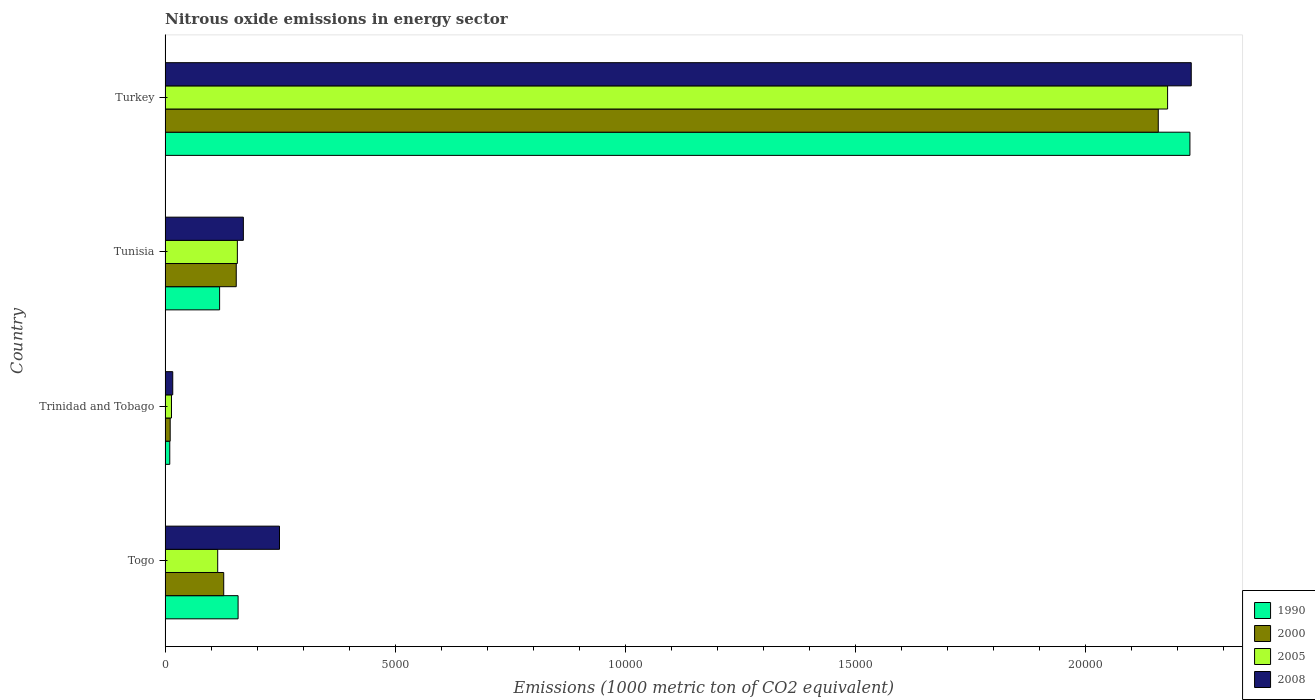How many different coloured bars are there?
Your answer should be compact. 4. How many groups of bars are there?
Make the answer very short. 4. Are the number of bars per tick equal to the number of legend labels?
Make the answer very short. Yes. How many bars are there on the 4th tick from the bottom?
Your answer should be compact. 4. What is the label of the 3rd group of bars from the top?
Offer a very short reply. Trinidad and Tobago. In how many cases, is the number of bars for a given country not equal to the number of legend labels?
Your answer should be compact. 0. What is the amount of nitrous oxide emitted in 2008 in Togo?
Your answer should be very brief. 2485.1. Across all countries, what is the maximum amount of nitrous oxide emitted in 1990?
Keep it short and to the point. 2.23e+04. Across all countries, what is the minimum amount of nitrous oxide emitted in 2005?
Your response must be concise. 138.8. In which country was the amount of nitrous oxide emitted in 2008 minimum?
Your answer should be compact. Trinidad and Tobago. What is the total amount of nitrous oxide emitted in 2008 in the graph?
Your response must be concise. 2.66e+04. What is the difference between the amount of nitrous oxide emitted in 2008 in Trinidad and Tobago and that in Turkey?
Provide a short and direct response. -2.21e+04. What is the difference between the amount of nitrous oxide emitted in 1990 in Togo and the amount of nitrous oxide emitted in 2005 in Turkey?
Keep it short and to the point. -2.02e+04. What is the average amount of nitrous oxide emitted in 2008 per country?
Your answer should be compact. 6660.77. What is the difference between the amount of nitrous oxide emitted in 2005 and amount of nitrous oxide emitted in 1990 in Trinidad and Tobago?
Provide a short and direct response. 37.5. In how many countries, is the amount of nitrous oxide emitted in 2008 greater than 11000 1000 metric ton?
Your answer should be very brief. 1. What is the ratio of the amount of nitrous oxide emitted in 1990 in Trinidad and Tobago to that in Turkey?
Keep it short and to the point. 0. Is the difference between the amount of nitrous oxide emitted in 2005 in Togo and Tunisia greater than the difference between the amount of nitrous oxide emitted in 1990 in Togo and Tunisia?
Offer a very short reply. No. What is the difference between the highest and the second highest amount of nitrous oxide emitted in 2008?
Make the answer very short. 1.98e+04. What is the difference between the highest and the lowest amount of nitrous oxide emitted in 2008?
Your answer should be compact. 2.21e+04. Is it the case that in every country, the sum of the amount of nitrous oxide emitted in 2005 and amount of nitrous oxide emitted in 2008 is greater than the sum of amount of nitrous oxide emitted in 1990 and amount of nitrous oxide emitted in 2000?
Give a very brief answer. No. How many bars are there?
Offer a terse response. 16. What is the difference between two consecutive major ticks on the X-axis?
Give a very brief answer. 5000. Where does the legend appear in the graph?
Ensure brevity in your answer.  Bottom right. How are the legend labels stacked?
Offer a terse response. Vertical. What is the title of the graph?
Provide a short and direct response. Nitrous oxide emissions in energy sector. What is the label or title of the X-axis?
Offer a terse response. Emissions (1000 metric ton of CO2 equivalent). What is the Emissions (1000 metric ton of CO2 equivalent) of 1990 in Togo?
Keep it short and to the point. 1585.7. What is the Emissions (1000 metric ton of CO2 equivalent) in 2000 in Togo?
Make the answer very short. 1273.3. What is the Emissions (1000 metric ton of CO2 equivalent) of 2005 in Togo?
Your answer should be very brief. 1142.8. What is the Emissions (1000 metric ton of CO2 equivalent) of 2008 in Togo?
Offer a terse response. 2485.1. What is the Emissions (1000 metric ton of CO2 equivalent) of 1990 in Trinidad and Tobago?
Your answer should be compact. 101.3. What is the Emissions (1000 metric ton of CO2 equivalent) of 2000 in Trinidad and Tobago?
Your response must be concise. 110.5. What is the Emissions (1000 metric ton of CO2 equivalent) in 2005 in Trinidad and Tobago?
Provide a short and direct response. 138.8. What is the Emissions (1000 metric ton of CO2 equivalent) of 2008 in Trinidad and Tobago?
Your answer should be compact. 166.3. What is the Emissions (1000 metric ton of CO2 equivalent) of 1990 in Tunisia?
Give a very brief answer. 1184.1. What is the Emissions (1000 metric ton of CO2 equivalent) of 2000 in Tunisia?
Keep it short and to the point. 1545.6. What is the Emissions (1000 metric ton of CO2 equivalent) in 2005 in Tunisia?
Your response must be concise. 1569.7. What is the Emissions (1000 metric ton of CO2 equivalent) of 2008 in Tunisia?
Your answer should be compact. 1700. What is the Emissions (1000 metric ton of CO2 equivalent) in 1990 in Turkey?
Ensure brevity in your answer.  2.23e+04. What is the Emissions (1000 metric ton of CO2 equivalent) of 2000 in Turkey?
Offer a very short reply. 2.16e+04. What is the Emissions (1000 metric ton of CO2 equivalent) of 2005 in Turkey?
Offer a very short reply. 2.18e+04. What is the Emissions (1000 metric ton of CO2 equivalent) in 2008 in Turkey?
Offer a very short reply. 2.23e+04. Across all countries, what is the maximum Emissions (1000 metric ton of CO2 equivalent) of 1990?
Keep it short and to the point. 2.23e+04. Across all countries, what is the maximum Emissions (1000 metric ton of CO2 equivalent) of 2000?
Your answer should be very brief. 2.16e+04. Across all countries, what is the maximum Emissions (1000 metric ton of CO2 equivalent) of 2005?
Offer a terse response. 2.18e+04. Across all countries, what is the maximum Emissions (1000 metric ton of CO2 equivalent) of 2008?
Provide a succinct answer. 2.23e+04. Across all countries, what is the minimum Emissions (1000 metric ton of CO2 equivalent) of 1990?
Make the answer very short. 101.3. Across all countries, what is the minimum Emissions (1000 metric ton of CO2 equivalent) of 2000?
Your answer should be compact. 110.5. Across all countries, what is the minimum Emissions (1000 metric ton of CO2 equivalent) of 2005?
Offer a very short reply. 138.8. Across all countries, what is the minimum Emissions (1000 metric ton of CO2 equivalent) in 2008?
Ensure brevity in your answer.  166.3. What is the total Emissions (1000 metric ton of CO2 equivalent) in 1990 in the graph?
Ensure brevity in your answer.  2.51e+04. What is the total Emissions (1000 metric ton of CO2 equivalent) in 2000 in the graph?
Provide a short and direct response. 2.45e+04. What is the total Emissions (1000 metric ton of CO2 equivalent) in 2005 in the graph?
Offer a very short reply. 2.46e+04. What is the total Emissions (1000 metric ton of CO2 equivalent) of 2008 in the graph?
Your response must be concise. 2.66e+04. What is the difference between the Emissions (1000 metric ton of CO2 equivalent) of 1990 in Togo and that in Trinidad and Tobago?
Provide a succinct answer. 1484.4. What is the difference between the Emissions (1000 metric ton of CO2 equivalent) in 2000 in Togo and that in Trinidad and Tobago?
Make the answer very short. 1162.8. What is the difference between the Emissions (1000 metric ton of CO2 equivalent) of 2005 in Togo and that in Trinidad and Tobago?
Your response must be concise. 1004. What is the difference between the Emissions (1000 metric ton of CO2 equivalent) in 2008 in Togo and that in Trinidad and Tobago?
Your answer should be compact. 2318.8. What is the difference between the Emissions (1000 metric ton of CO2 equivalent) of 1990 in Togo and that in Tunisia?
Your answer should be compact. 401.6. What is the difference between the Emissions (1000 metric ton of CO2 equivalent) of 2000 in Togo and that in Tunisia?
Ensure brevity in your answer.  -272.3. What is the difference between the Emissions (1000 metric ton of CO2 equivalent) in 2005 in Togo and that in Tunisia?
Your answer should be compact. -426.9. What is the difference between the Emissions (1000 metric ton of CO2 equivalent) in 2008 in Togo and that in Tunisia?
Provide a short and direct response. 785.1. What is the difference between the Emissions (1000 metric ton of CO2 equivalent) in 1990 in Togo and that in Turkey?
Keep it short and to the point. -2.07e+04. What is the difference between the Emissions (1000 metric ton of CO2 equivalent) in 2000 in Togo and that in Turkey?
Make the answer very short. -2.03e+04. What is the difference between the Emissions (1000 metric ton of CO2 equivalent) of 2005 in Togo and that in Turkey?
Offer a very short reply. -2.06e+04. What is the difference between the Emissions (1000 metric ton of CO2 equivalent) of 2008 in Togo and that in Turkey?
Offer a terse response. -1.98e+04. What is the difference between the Emissions (1000 metric ton of CO2 equivalent) in 1990 in Trinidad and Tobago and that in Tunisia?
Offer a very short reply. -1082.8. What is the difference between the Emissions (1000 metric ton of CO2 equivalent) in 2000 in Trinidad and Tobago and that in Tunisia?
Offer a terse response. -1435.1. What is the difference between the Emissions (1000 metric ton of CO2 equivalent) in 2005 in Trinidad and Tobago and that in Tunisia?
Keep it short and to the point. -1430.9. What is the difference between the Emissions (1000 metric ton of CO2 equivalent) in 2008 in Trinidad and Tobago and that in Tunisia?
Your answer should be very brief. -1533.7. What is the difference between the Emissions (1000 metric ton of CO2 equivalent) of 1990 in Trinidad and Tobago and that in Turkey?
Your response must be concise. -2.22e+04. What is the difference between the Emissions (1000 metric ton of CO2 equivalent) in 2000 in Trinidad and Tobago and that in Turkey?
Keep it short and to the point. -2.15e+04. What is the difference between the Emissions (1000 metric ton of CO2 equivalent) in 2005 in Trinidad and Tobago and that in Turkey?
Keep it short and to the point. -2.16e+04. What is the difference between the Emissions (1000 metric ton of CO2 equivalent) of 2008 in Trinidad and Tobago and that in Turkey?
Provide a succinct answer. -2.21e+04. What is the difference between the Emissions (1000 metric ton of CO2 equivalent) of 1990 in Tunisia and that in Turkey?
Ensure brevity in your answer.  -2.11e+04. What is the difference between the Emissions (1000 metric ton of CO2 equivalent) in 2000 in Tunisia and that in Turkey?
Your answer should be compact. -2.00e+04. What is the difference between the Emissions (1000 metric ton of CO2 equivalent) in 2005 in Tunisia and that in Turkey?
Provide a succinct answer. -2.02e+04. What is the difference between the Emissions (1000 metric ton of CO2 equivalent) in 2008 in Tunisia and that in Turkey?
Keep it short and to the point. -2.06e+04. What is the difference between the Emissions (1000 metric ton of CO2 equivalent) in 1990 in Togo and the Emissions (1000 metric ton of CO2 equivalent) in 2000 in Trinidad and Tobago?
Ensure brevity in your answer.  1475.2. What is the difference between the Emissions (1000 metric ton of CO2 equivalent) of 1990 in Togo and the Emissions (1000 metric ton of CO2 equivalent) of 2005 in Trinidad and Tobago?
Provide a succinct answer. 1446.9. What is the difference between the Emissions (1000 metric ton of CO2 equivalent) in 1990 in Togo and the Emissions (1000 metric ton of CO2 equivalent) in 2008 in Trinidad and Tobago?
Give a very brief answer. 1419.4. What is the difference between the Emissions (1000 metric ton of CO2 equivalent) in 2000 in Togo and the Emissions (1000 metric ton of CO2 equivalent) in 2005 in Trinidad and Tobago?
Offer a very short reply. 1134.5. What is the difference between the Emissions (1000 metric ton of CO2 equivalent) in 2000 in Togo and the Emissions (1000 metric ton of CO2 equivalent) in 2008 in Trinidad and Tobago?
Give a very brief answer. 1107. What is the difference between the Emissions (1000 metric ton of CO2 equivalent) of 2005 in Togo and the Emissions (1000 metric ton of CO2 equivalent) of 2008 in Trinidad and Tobago?
Give a very brief answer. 976.5. What is the difference between the Emissions (1000 metric ton of CO2 equivalent) of 1990 in Togo and the Emissions (1000 metric ton of CO2 equivalent) of 2000 in Tunisia?
Your response must be concise. 40.1. What is the difference between the Emissions (1000 metric ton of CO2 equivalent) of 1990 in Togo and the Emissions (1000 metric ton of CO2 equivalent) of 2005 in Tunisia?
Give a very brief answer. 16. What is the difference between the Emissions (1000 metric ton of CO2 equivalent) in 1990 in Togo and the Emissions (1000 metric ton of CO2 equivalent) in 2008 in Tunisia?
Offer a very short reply. -114.3. What is the difference between the Emissions (1000 metric ton of CO2 equivalent) of 2000 in Togo and the Emissions (1000 metric ton of CO2 equivalent) of 2005 in Tunisia?
Give a very brief answer. -296.4. What is the difference between the Emissions (1000 metric ton of CO2 equivalent) of 2000 in Togo and the Emissions (1000 metric ton of CO2 equivalent) of 2008 in Tunisia?
Offer a very short reply. -426.7. What is the difference between the Emissions (1000 metric ton of CO2 equivalent) of 2005 in Togo and the Emissions (1000 metric ton of CO2 equivalent) of 2008 in Tunisia?
Provide a short and direct response. -557.2. What is the difference between the Emissions (1000 metric ton of CO2 equivalent) in 1990 in Togo and the Emissions (1000 metric ton of CO2 equivalent) in 2000 in Turkey?
Keep it short and to the point. -2.00e+04. What is the difference between the Emissions (1000 metric ton of CO2 equivalent) of 1990 in Togo and the Emissions (1000 metric ton of CO2 equivalent) of 2005 in Turkey?
Offer a terse response. -2.02e+04. What is the difference between the Emissions (1000 metric ton of CO2 equivalent) of 1990 in Togo and the Emissions (1000 metric ton of CO2 equivalent) of 2008 in Turkey?
Provide a succinct answer. -2.07e+04. What is the difference between the Emissions (1000 metric ton of CO2 equivalent) in 2000 in Togo and the Emissions (1000 metric ton of CO2 equivalent) in 2005 in Turkey?
Offer a terse response. -2.05e+04. What is the difference between the Emissions (1000 metric ton of CO2 equivalent) of 2000 in Togo and the Emissions (1000 metric ton of CO2 equivalent) of 2008 in Turkey?
Your response must be concise. -2.10e+04. What is the difference between the Emissions (1000 metric ton of CO2 equivalent) in 2005 in Togo and the Emissions (1000 metric ton of CO2 equivalent) in 2008 in Turkey?
Give a very brief answer. -2.11e+04. What is the difference between the Emissions (1000 metric ton of CO2 equivalent) in 1990 in Trinidad and Tobago and the Emissions (1000 metric ton of CO2 equivalent) in 2000 in Tunisia?
Keep it short and to the point. -1444.3. What is the difference between the Emissions (1000 metric ton of CO2 equivalent) in 1990 in Trinidad and Tobago and the Emissions (1000 metric ton of CO2 equivalent) in 2005 in Tunisia?
Keep it short and to the point. -1468.4. What is the difference between the Emissions (1000 metric ton of CO2 equivalent) of 1990 in Trinidad and Tobago and the Emissions (1000 metric ton of CO2 equivalent) of 2008 in Tunisia?
Your answer should be compact. -1598.7. What is the difference between the Emissions (1000 metric ton of CO2 equivalent) in 2000 in Trinidad and Tobago and the Emissions (1000 metric ton of CO2 equivalent) in 2005 in Tunisia?
Provide a succinct answer. -1459.2. What is the difference between the Emissions (1000 metric ton of CO2 equivalent) in 2000 in Trinidad and Tobago and the Emissions (1000 metric ton of CO2 equivalent) in 2008 in Tunisia?
Provide a succinct answer. -1589.5. What is the difference between the Emissions (1000 metric ton of CO2 equivalent) of 2005 in Trinidad and Tobago and the Emissions (1000 metric ton of CO2 equivalent) of 2008 in Tunisia?
Provide a short and direct response. -1561.2. What is the difference between the Emissions (1000 metric ton of CO2 equivalent) of 1990 in Trinidad and Tobago and the Emissions (1000 metric ton of CO2 equivalent) of 2000 in Turkey?
Ensure brevity in your answer.  -2.15e+04. What is the difference between the Emissions (1000 metric ton of CO2 equivalent) in 1990 in Trinidad and Tobago and the Emissions (1000 metric ton of CO2 equivalent) in 2005 in Turkey?
Provide a succinct answer. -2.17e+04. What is the difference between the Emissions (1000 metric ton of CO2 equivalent) of 1990 in Trinidad and Tobago and the Emissions (1000 metric ton of CO2 equivalent) of 2008 in Turkey?
Your answer should be very brief. -2.22e+04. What is the difference between the Emissions (1000 metric ton of CO2 equivalent) in 2000 in Trinidad and Tobago and the Emissions (1000 metric ton of CO2 equivalent) in 2005 in Turkey?
Your response must be concise. -2.17e+04. What is the difference between the Emissions (1000 metric ton of CO2 equivalent) of 2000 in Trinidad and Tobago and the Emissions (1000 metric ton of CO2 equivalent) of 2008 in Turkey?
Keep it short and to the point. -2.22e+04. What is the difference between the Emissions (1000 metric ton of CO2 equivalent) in 2005 in Trinidad and Tobago and the Emissions (1000 metric ton of CO2 equivalent) in 2008 in Turkey?
Your response must be concise. -2.22e+04. What is the difference between the Emissions (1000 metric ton of CO2 equivalent) of 1990 in Tunisia and the Emissions (1000 metric ton of CO2 equivalent) of 2000 in Turkey?
Offer a very short reply. -2.04e+04. What is the difference between the Emissions (1000 metric ton of CO2 equivalent) in 1990 in Tunisia and the Emissions (1000 metric ton of CO2 equivalent) in 2005 in Turkey?
Offer a terse response. -2.06e+04. What is the difference between the Emissions (1000 metric ton of CO2 equivalent) in 1990 in Tunisia and the Emissions (1000 metric ton of CO2 equivalent) in 2008 in Turkey?
Your answer should be compact. -2.11e+04. What is the difference between the Emissions (1000 metric ton of CO2 equivalent) of 2000 in Tunisia and the Emissions (1000 metric ton of CO2 equivalent) of 2005 in Turkey?
Your answer should be very brief. -2.02e+04. What is the difference between the Emissions (1000 metric ton of CO2 equivalent) of 2000 in Tunisia and the Emissions (1000 metric ton of CO2 equivalent) of 2008 in Turkey?
Your answer should be compact. -2.07e+04. What is the difference between the Emissions (1000 metric ton of CO2 equivalent) in 2005 in Tunisia and the Emissions (1000 metric ton of CO2 equivalent) in 2008 in Turkey?
Offer a terse response. -2.07e+04. What is the average Emissions (1000 metric ton of CO2 equivalent) of 1990 per country?
Offer a terse response. 6283.5. What is the average Emissions (1000 metric ton of CO2 equivalent) of 2000 per country?
Provide a short and direct response. 6126.18. What is the average Emissions (1000 metric ton of CO2 equivalent) in 2005 per country?
Offer a very short reply. 6157.27. What is the average Emissions (1000 metric ton of CO2 equivalent) in 2008 per country?
Provide a short and direct response. 6660.77. What is the difference between the Emissions (1000 metric ton of CO2 equivalent) of 1990 and Emissions (1000 metric ton of CO2 equivalent) of 2000 in Togo?
Provide a succinct answer. 312.4. What is the difference between the Emissions (1000 metric ton of CO2 equivalent) of 1990 and Emissions (1000 metric ton of CO2 equivalent) of 2005 in Togo?
Provide a short and direct response. 442.9. What is the difference between the Emissions (1000 metric ton of CO2 equivalent) of 1990 and Emissions (1000 metric ton of CO2 equivalent) of 2008 in Togo?
Offer a terse response. -899.4. What is the difference between the Emissions (1000 metric ton of CO2 equivalent) in 2000 and Emissions (1000 metric ton of CO2 equivalent) in 2005 in Togo?
Give a very brief answer. 130.5. What is the difference between the Emissions (1000 metric ton of CO2 equivalent) of 2000 and Emissions (1000 metric ton of CO2 equivalent) of 2008 in Togo?
Your response must be concise. -1211.8. What is the difference between the Emissions (1000 metric ton of CO2 equivalent) in 2005 and Emissions (1000 metric ton of CO2 equivalent) in 2008 in Togo?
Offer a very short reply. -1342.3. What is the difference between the Emissions (1000 metric ton of CO2 equivalent) of 1990 and Emissions (1000 metric ton of CO2 equivalent) of 2000 in Trinidad and Tobago?
Provide a short and direct response. -9.2. What is the difference between the Emissions (1000 metric ton of CO2 equivalent) of 1990 and Emissions (1000 metric ton of CO2 equivalent) of 2005 in Trinidad and Tobago?
Ensure brevity in your answer.  -37.5. What is the difference between the Emissions (1000 metric ton of CO2 equivalent) of 1990 and Emissions (1000 metric ton of CO2 equivalent) of 2008 in Trinidad and Tobago?
Provide a short and direct response. -65. What is the difference between the Emissions (1000 metric ton of CO2 equivalent) of 2000 and Emissions (1000 metric ton of CO2 equivalent) of 2005 in Trinidad and Tobago?
Give a very brief answer. -28.3. What is the difference between the Emissions (1000 metric ton of CO2 equivalent) in 2000 and Emissions (1000 metric ton of CO2 equivalent) in 2008 in Trinidad and Tobago?
Make the answer very short. -55.8. What is the difference between the Emissions (1000 metric ton of CO2 equivalent) in 2005 and Emissions (1000 metric ton of CO2 equivalent) in 2008 in Trinidad and Tobago?
Give a very brief answer. -27.5. What is the difference between the Emissions (1000 metric ton of CO2 equivalent) in 1990 and Emissions (1000 metric ton of CO2 equivalent) in 2000 in Tunisia?
Your answer should be very brief. -361.5. What is the difference between the Emissions (1000 metric ton of CO2 equivalent) of 1990 and Emissions (1000 metric ton of CO2 equivalent) of 2005 in Tunisia?
Make the answer very short. -385.6. What is the difference between the Emissions (1000 metric ton of CO2 equivalent) in 1990 and Emissions (1000 metric ton of CO2 equivalent) in 2008 in Tunisia?
Your response must be concise. -515.9. What is the difference between the Emissions (1000 metric ton of CO2 equivalent) in 2000 and Emissions (1000 metric ton of CO2 equivalent) in 2005 in Tunisia?
Keep it short and to the point. -24.1. What is the difference between the Emissions (1000 metric ton of CO2 equivalent) in 2000 and Emissions (1000 metric ton of CO2 equivalent) in 2008 in Tunisia?
Your answer should be compact. -154.4. What is the difference between the Emissions (1000 metric ton of CO2 equivalent) of 2005 and Emissions (1000 metric ton of CO2 equivalent) of 2008 in Tunisia?
Your answer should be compact. -130.3. What is the difference between the Emissions (1000 metric ton of CO2 equivalent) in 1990 and Emissions (1000 metric ton of CO2 equivalent) in 2000 in Turkey?
Ensure brevity in your answer.  687.6. What is the difference between the Emissions (1000 metric ton of CO2 equivalent) in 1990 and Emissions (1000 metric ton of CO2 equivalent) in 2005 in Turkey?
Offer a very short reply. 485.1. What is the difference between the Emissions (1000 metric ton of CO2 equivalent) of 1990 and Emissions (1000 metric ton of CO2 equivalent) of 2008 in Turkey?
Keep it short and to the point. -28.8. What is the difference between the Emissions (1000 metric ton of CO2 equivalent) of 2000 and Emissions (1000 metric ton of CO2 equivalent) of 2005 in Turkey?
Provide a short and direct response. -202.5. What is the difference between the Emissions (1000 metric ton of CO2 equivalent) in 2000 and Emissions (1000 metric ton of CO2 equivalent) in 2008 in Turkey?
Your response must be concise. -716.4. What is the difference between the Emissions (1000 metric ton of CO2 equivalent) in 2005 and Emissions (1000 metric ton of CO2 equivalent) in 2008 in Turkey?
Give a very brief answer. -513.9. What is the ratio of the Emissions (1000 metric ton of CO2 equivalent) of 1990 in Togo to that in Trinidad and Tobago?
Keep it short and to the point. 15.65. What is the ratio of the Emissions (1000 metric ton of CO2 equivalent) of 2000 in Togo to that in Trinidad and Tobago?
Provide a short and direct response. 11.52. What is the ratio of the Emissions (1000 metric ton of CO2 equivalent) in 2005 in Togo to that in Trinidad and Tobago?
Offer a terse response. 8.23. What is the ratio of the Emissions (1000 metric ton of CO2 equivalent) of 2008 in Togo to that in Trinidad and Tobago?
Ensure brevity in your answer.  14.94. What is the ratio of the Emissions (1000 metric ton of CO2 equivalent) of 1990 in Togo to that in Tunisia?
Give a very brief answer. 1.34. What is the ratio of the Emissions (1000 metric ton of CO2 equivalent) in 2000 in Togo to that in Tunisia?
Provide a succinct answer. 0.82. What is the ratio of the Emissions (1000 metric ton of CO2 equivalent) of 2005 in Togo to that in Tunisia?
Provide a short and direct response. 0.73. What is the ratio of the Emissions (1000 metric ton of CO2 equivalent) of 2008 in Togo to that in Tunisia?
Make the answer very short. 1.46. What is the ratio of the Emissions (1000 metric ton of CO2 equivalent) of 1990 in Togo to that in Turkey?
Provide a succinct answer. 0.07. What is the ratio of the Emissions (1000 metric ton of CO2 equivalent) of 2000 in Togo to that in Turkey?
Offer a very short reply. 0.06. What is the ratio of the Emissions (1000 metric ton of CO2 equivalent) in 2005 in Togo to that in Turkey?
Provide a succinct answer. 0.05. What is the ratio of the Emissions (1000 metric ton of CO2 equivalent) of 2008 in Togo to that in Turkey?
Provide a short and direct response. 0.11. What is the ratio of the Emissions (1000 metric ton of CO2 equivalent) in 1990 in Trinidad and Tobago to that in Tunisia?
Keep it short and to the point. 0.09. What is the ratio of the Emissions (1000 metric ton of CO2 equivalent) in 2000 in Trinidad and Tobago to that in Tunisia?
Offer a very short reply. 0.07. What is the ratio of the Emissions (1000 metric ton of CO2 equivalent) in 2005 in Trinidad and Tobago to that in Tunisia?
Offer a very short reply. 0.09. What is the ratio of the Emissions (1000 metric ton of CO2 equivalent) of 2008 in Trinidad and Tobago to that in Tunisia?
Your answer should be compact. 0.1. What is the ratio of the Emissions (1000 metric ton of CO2 equivalent) in 1990 in Trinidad and Tobago to that in Turkey?
Make the answer very short. 0. What is the ratio of the Emissions (1000 metric ton of CO2 equivalent) of 2000 in Trinidad and Tobago to that in Turkey?
Offer a very short reply. 0.01. What is the ratio of the Emissions (1000 metric ton of CO2 equivalent) of 2005 in Trinidad and Tobago to that in Turkey?
Your response must be concise. 0.01. What is the ratio of the Emissions (1000 metric ton of CO2 equivalent) of 2008 in Trinidad and Tobago to that in Turkey?
Offer a terse response. 0.01. What is the ratio of the Emissions (1000 metric ton of CO2 equivalent) of 1990 in Tunisia to that in Turkey?
Offer a very short reply. 0.05. What is the ratio of the Emissions (1000 metric ton of CO2 equivalent) in 2000 in Tunisia to that in Turkey?
Ensure brevity in your answer.  0.07. What is the ratio of the Emissions (1000 metric ton of CO2 equivalent) of 2005 in Tunisia to that in Turkey?
Give a very brief answer. 0.07. What is the ratio of the Emissions (1000 metric ton of CO2 equivalent) of 2008 in Tunisia to that in Turkey?
Offer a terse response. 0.08. What is the difference between the highest and the second highest Emissions (1000 metric ton of CO2 equivalent) of 1990?
Provide a succinct answer. 2.07e+04. What is the difference between the highest and the second highest Emissions (1000 metric ton of CO2 equivalent) in 2000?
Provide a short and direct response. 2.00e+04. What is the difference between the highest and the second highest Emissions (1000 metric ton of CO2 equivalent) of 2005?
Provide a succinct answer. 2.02e+04. What is the difference between the highest and the second highest Emissions (1000 metric ton of CO2 equivalent) in 2008?
Your answer should be very brief. 1.98e+04. What is the difference between the highest and the lowest Emissions (1000 metric ton of CO2 equivalent) of 1990?
Ensure brevity in your answer.  2.22e+04. What is the difference between the highest and the lowest Emissions (1000 metric ton of CO2 equivalent) of 2000?
Provide a short and direct response. 2.15e+04. What is the difference between the highest and the lowest Emissions (1000 metric ton of CO2 equivalent) of 2005?
Offer a very short reply. 2.16e+04. What is the difference between the highest and the lowest Emissions (1000 metric ton of CO2 equivalent) in 2008?
Provide a short and direct response. 2.21e+04. 